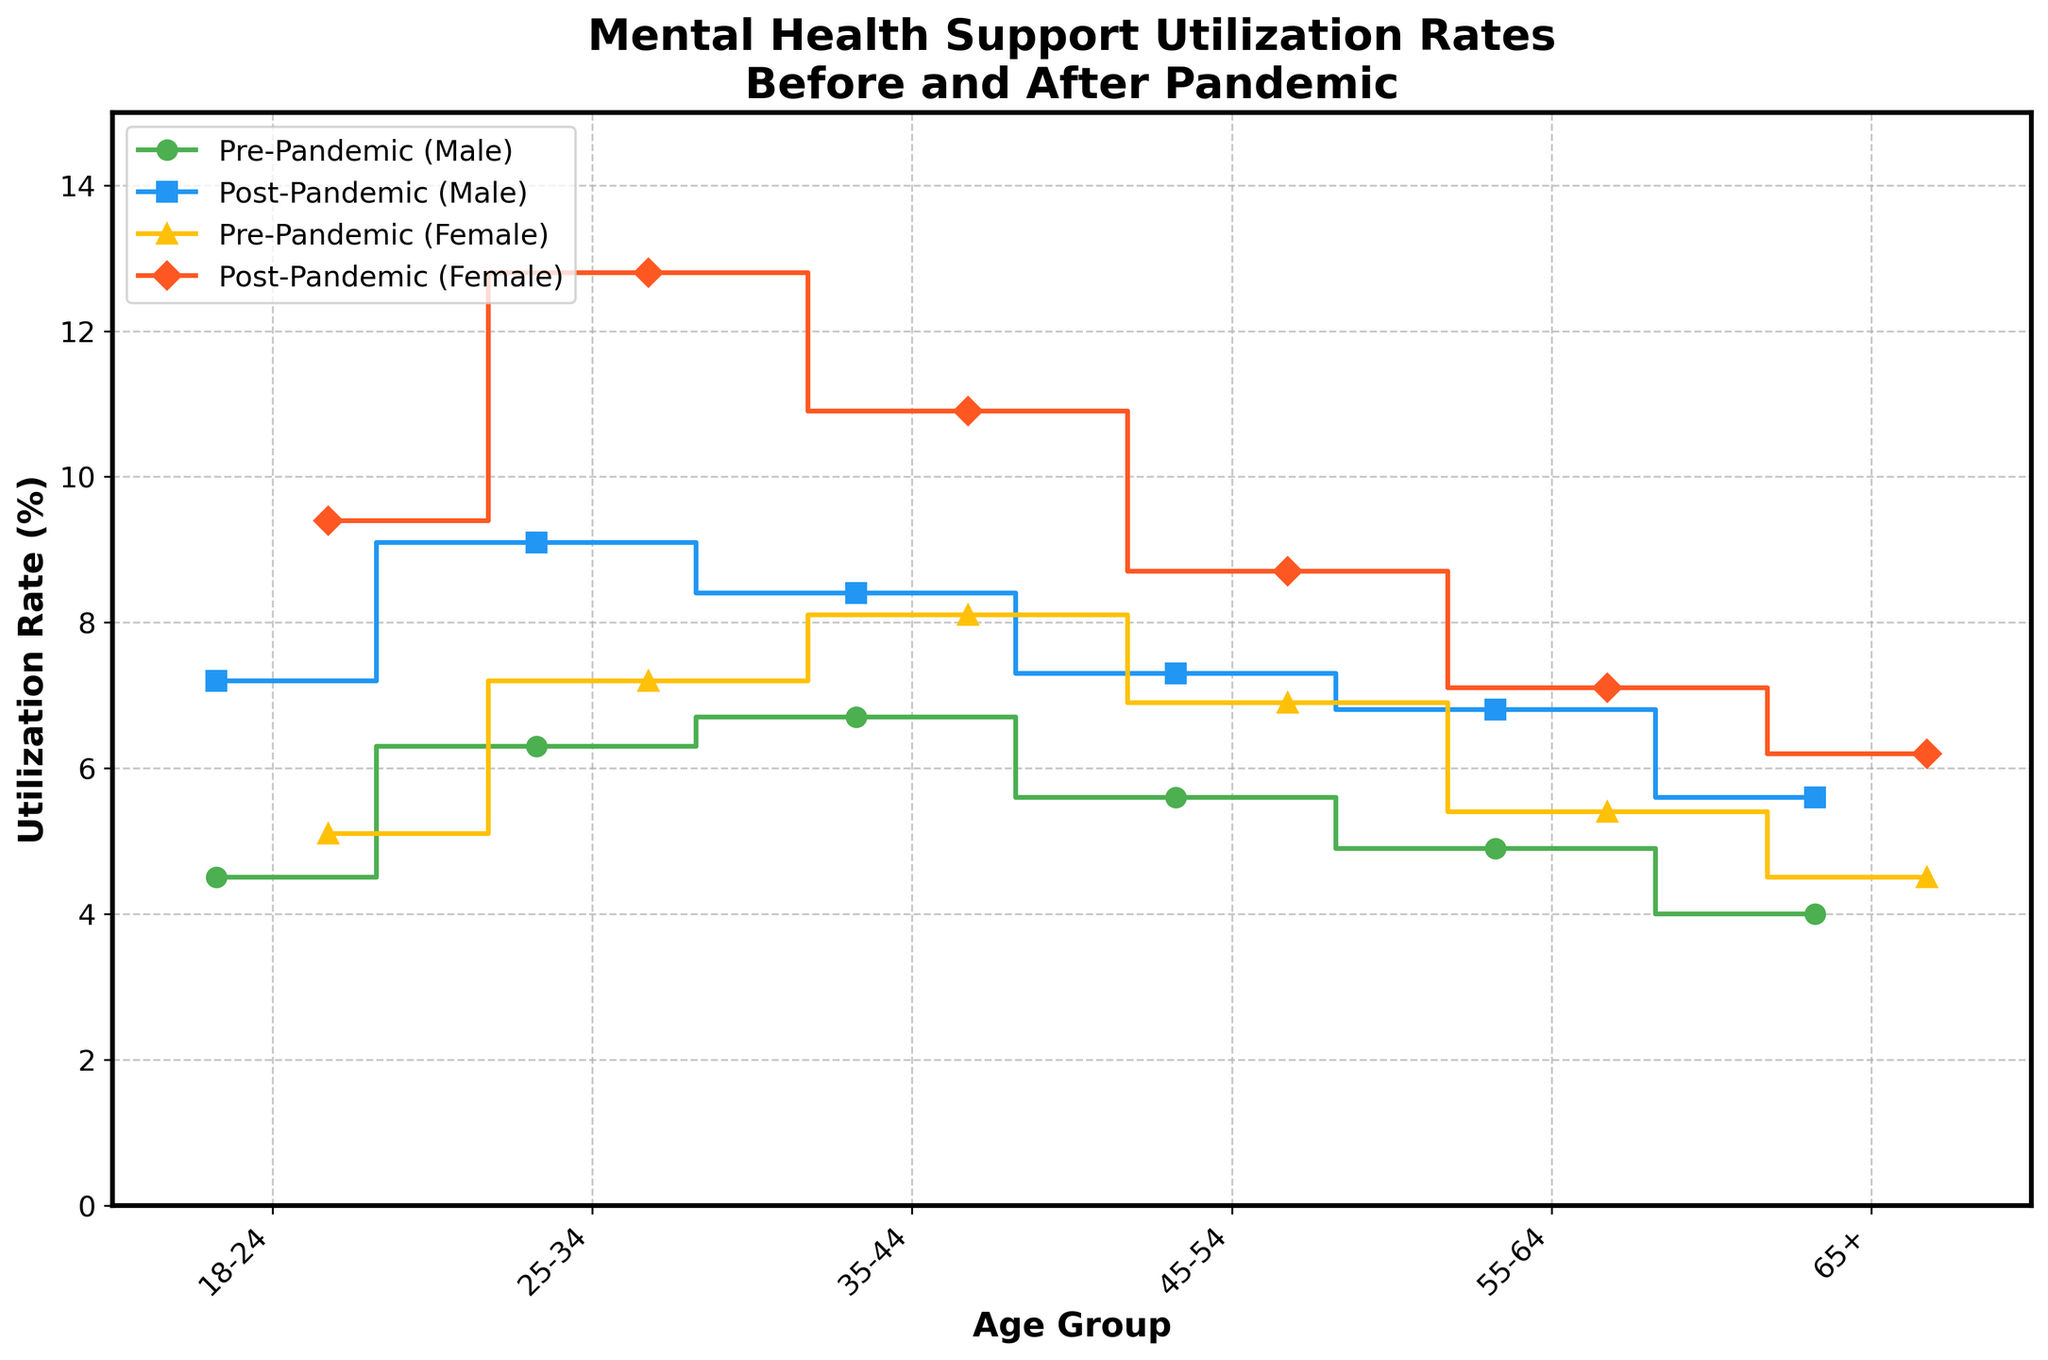What is the title of the figure? The title of the figure is usually located at the top and summarizes the data being presented. According to the data and code provided, it should be "Mental Health Support Utilization Rates\nBefore and After Pandemic".
Answer: Mental Health Support Utilization Rates\nBefore and After Pandemic What's the x-axis label? The x-axis label is usually positioned below the x-axis and describes what the axis represents. According to the code provided, the x-axis represents age groups and is labeled as "Age Group".
Answer: Age Group What age group saw the highest post-pandemic utilization rate among females? The step plot uses different colors and markers for various age groups and genders. To find the highest post-pandemic utilization rate, observe the highest point among the post-pandemic lines for females, which is represented by diamond markers in red color. The highest point for females is at the 25-34 age group.
Answer: 25-34 What age group saw the highest increase in utilization rate among males from pre-pandemic to post-pandemic? To determine the highest increase, look at both the pre-pandemic and post-pandemic lines for males and identify the age group where the gap between the steps is the widest. The age group 25-34 has a pre-pandemic rate of 6.3% and a post-pandemic rate of 9.1%, resulting in an increase of 2.8%, which is the highest.
Answer: 25-34 Which demographic had the lowest pre-pandemic utilization rate? For the lowest pre-pandemic rate, look at the line segments labeled "Pre-Pandemic" for both males and females and identify the lowest value. The 65+ age group (males) has the lowest pre-pandemic rate of 4.0%.
Answer: 65+, Male What is the difference in the post-pandemic utilization rate between the 18-24 age group for males and females? To find this difference, subtract the post-pandemic rate of males in the 18-24 group (7.2%) from that of females in the same group (9.4%). Thus, 9.4% - 7.2% = 2.2%.
Answer: 2.2% How did the utilization rate for females aged 45-54 change from pre-pandemic to post-pandemic? First, identify the pre-pandemic and post-pandemic rates for females aged 45-54. The pre-pandemic rate is 6.9%, and the post-pandemic rate is 8.7%. The change is calculated as 8.7% - 6.9% = 1.8%.
Answer: Increased by 1.8% Which gender saw a higher increase in mental health support utilization rates in the 35-44 age group? Compare the increase for both males and females in this age group. For males, the increase is 8.4% - 6.7% = 1.7%. For females, the increase is 10.9% - 8.1% = 2.8%. The females saw a higher increase.
Answer: Female What are the utilization rates for the 55-64 age group post-pandemic for both genders? Examine the post-pandemic series for both males and females within the 55-64 age group. According to the figure, the post-pandemic rates are 6.8% for males and 7.1% for females.
Answer: 6.8% for males, 7.1% for females In which gender and age group was the smallest change in utilization rates observed from pre-pandemic to post-pandemic? Look for the smallest gap between the pre-pandemic and post-pandemic steps across all gender and age groups. The 55-64 age group for females shows a change from 5.4% to 7.1%, a difference of only 0.3%, the smallest observed.
Answer: 55-64, Female 